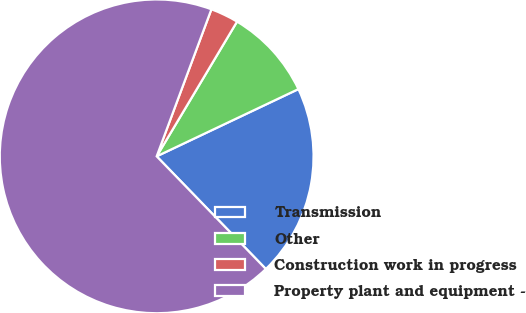Convert chart to OTSL. <chart><loc_0><loc_0><loc_500><loc_500><pie_chart><fcel>Transmission<fcel>Other<fcel>Construction work in progress<fcel>Property plant and equipment -<nl><fcel>19.8%<fcel>9.39%<fcel>2.89%<fcel>67.92%<nl></chart> 